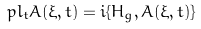<formula> <loc_0><loc_0><loc_500><loc_500>\ p l _ { t } A ( \xi , t ) = i \{ H _ { g } , A ( \xi , t ) \}</formula> 